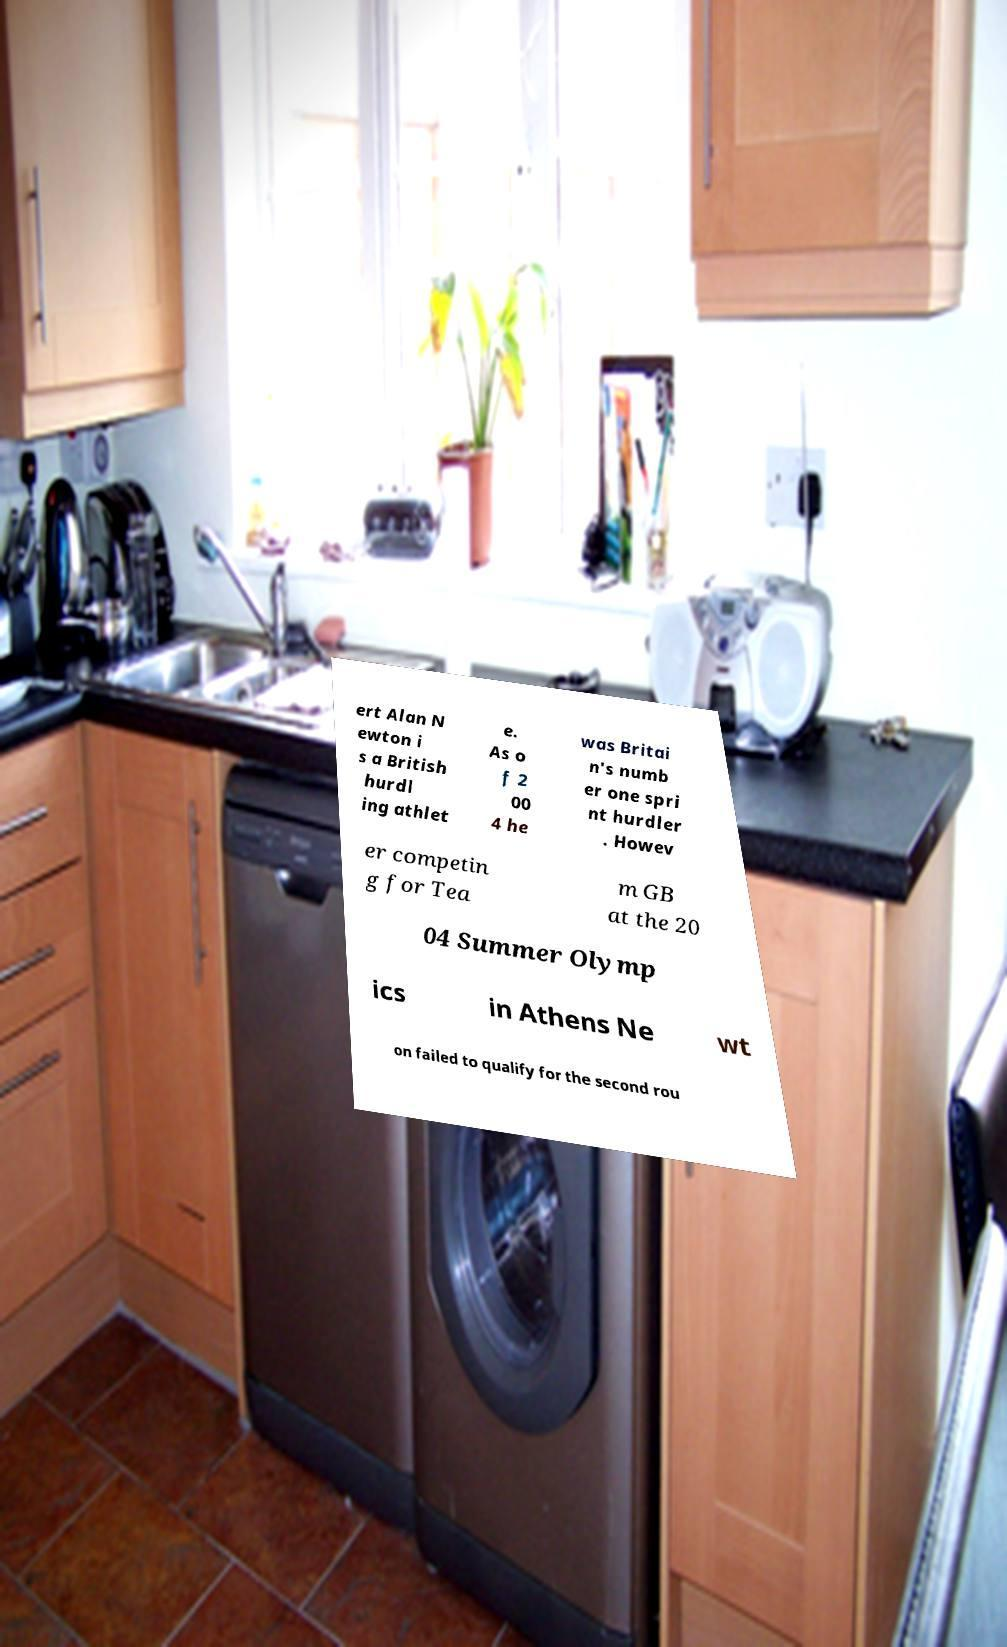Please read and relay the text visible in this image. What does it say? ert Alan N ewton i s a British hurdl ing athlet e. As o f 2 00 4 he was Britai n's numb er one spri nt hurdler . Howev er competin g for Tea m GB at the 20 04 Summer Olymp ics in Athens Ne wt on failed to qualify for the second rou 